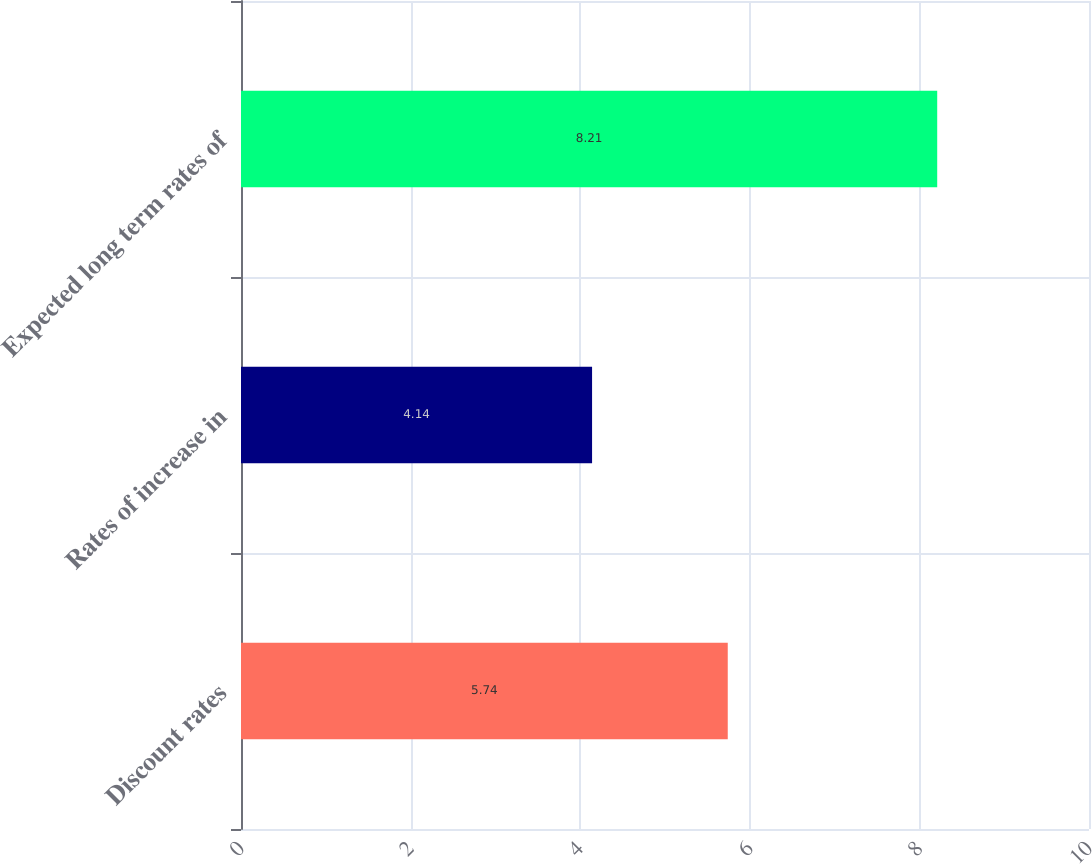<chart> <loc_0><loc_0><loc_500><loc_500><bar_chart><fcel>Discount rates<fcel>Rates of increase in<fcel>Expected long term rates of<nl><fcel>5.74<fcel>4.14<fcel>8.21<nl></chart> 